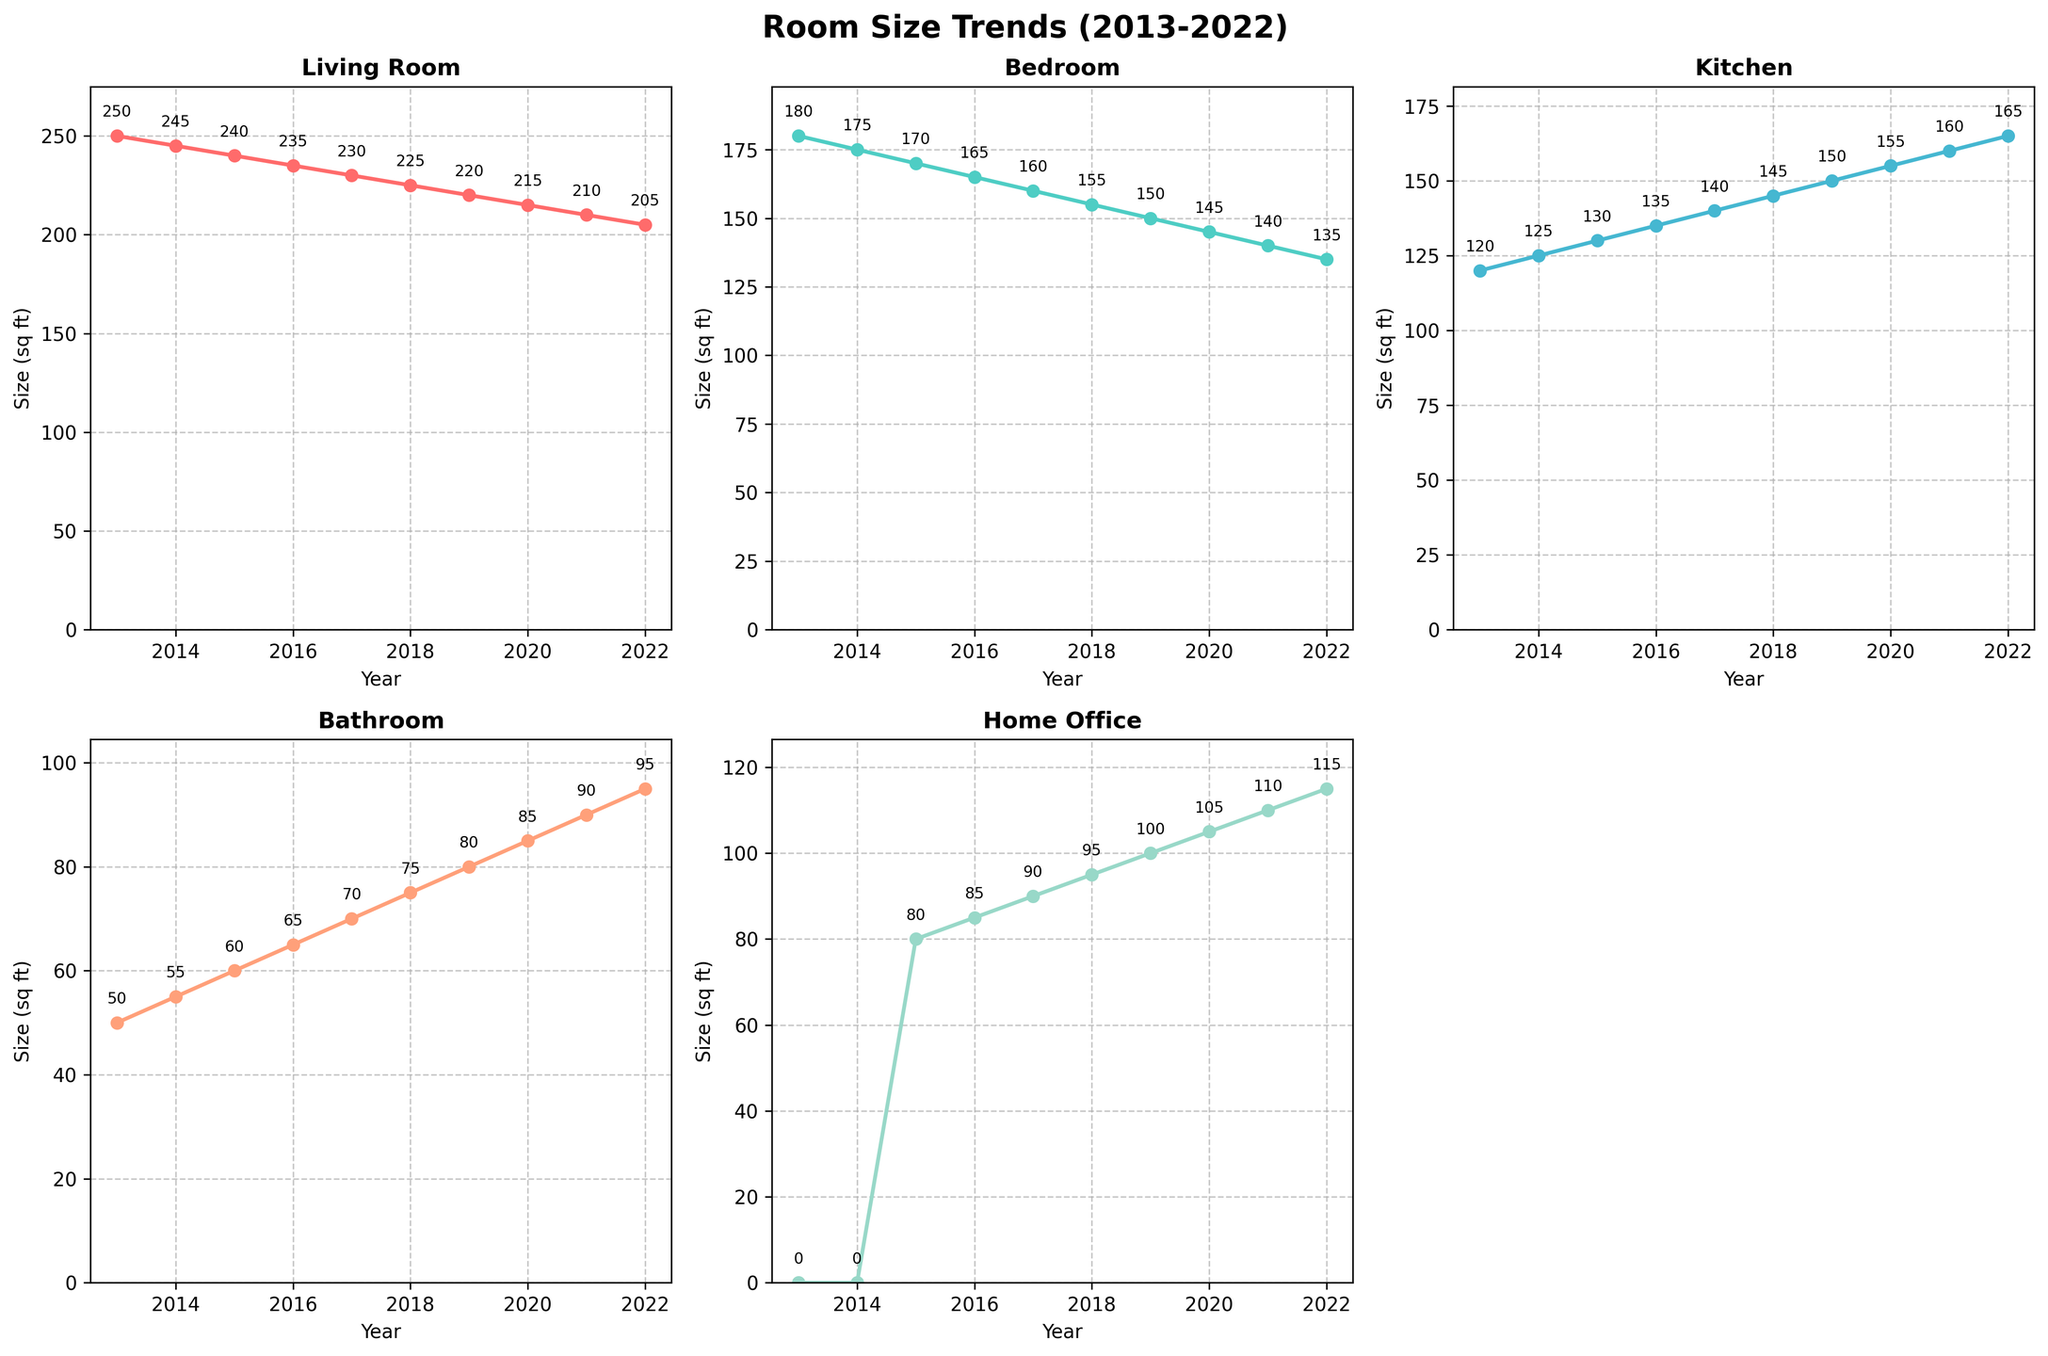What is the trend for the Living Room size over the past decade? The Living Room size decreases consistently from 250 sq ft in 2013 to 205 sq ft in 2022.
Answer: Decreasing What is the size of the Kitchen in 2019? Check the Kitchen subplot for the data point in the year 2019; the size in 2019 is 150 sq ft.
Answer: 150 sq ft Which room shows no size data for the year 2013? Observe the subplots for any room starting with no data in 2013. The Home Office subplot starts with a size of 0 sq ft.
Answer: Home Office On average, how much did the Bedroom size decrease per year from 2013 to 2022? Subtract the Bedroom size in 2022 from that in 2013 and divide by the number of years (180 sq ft - 135 sq ft) / (2022 - 2013) = 45 sq ft / 9 years.
Answer: 5 sq ft per year Which rooms consistently increase in size over the given time period? Identify the subplots with steady increasing trends from 2013 to 2022. The Bathroom and Home Office sizes consistently increase over the decade.
Answer: Bathroom, Home Office Which year marks the first data entry for the Home Office size? Check the Home Office subplot for the first non-zero data point; it appears in 2015.
Answer: 2015 By how much does the Kitchen size in 2022 differ from the Kitchen size in 2013? Subtract the Kitchen size in 2013 from that in 2022 (165 sq ft - 120 sq ft).
Answer: 45 sq ft Which room has the greatest total size reduction from 2013 to 2022? Calculate the size reduction for each room: Living Room decreases by 45 sq ft, Bedroom by 45 sq ft, Kitchen increases, Bathroom increases, Home Office increases. Both Living Room and Bedroom have the greatest reduction of 45 sq ft.
Answer: Living Room, Bedroom 